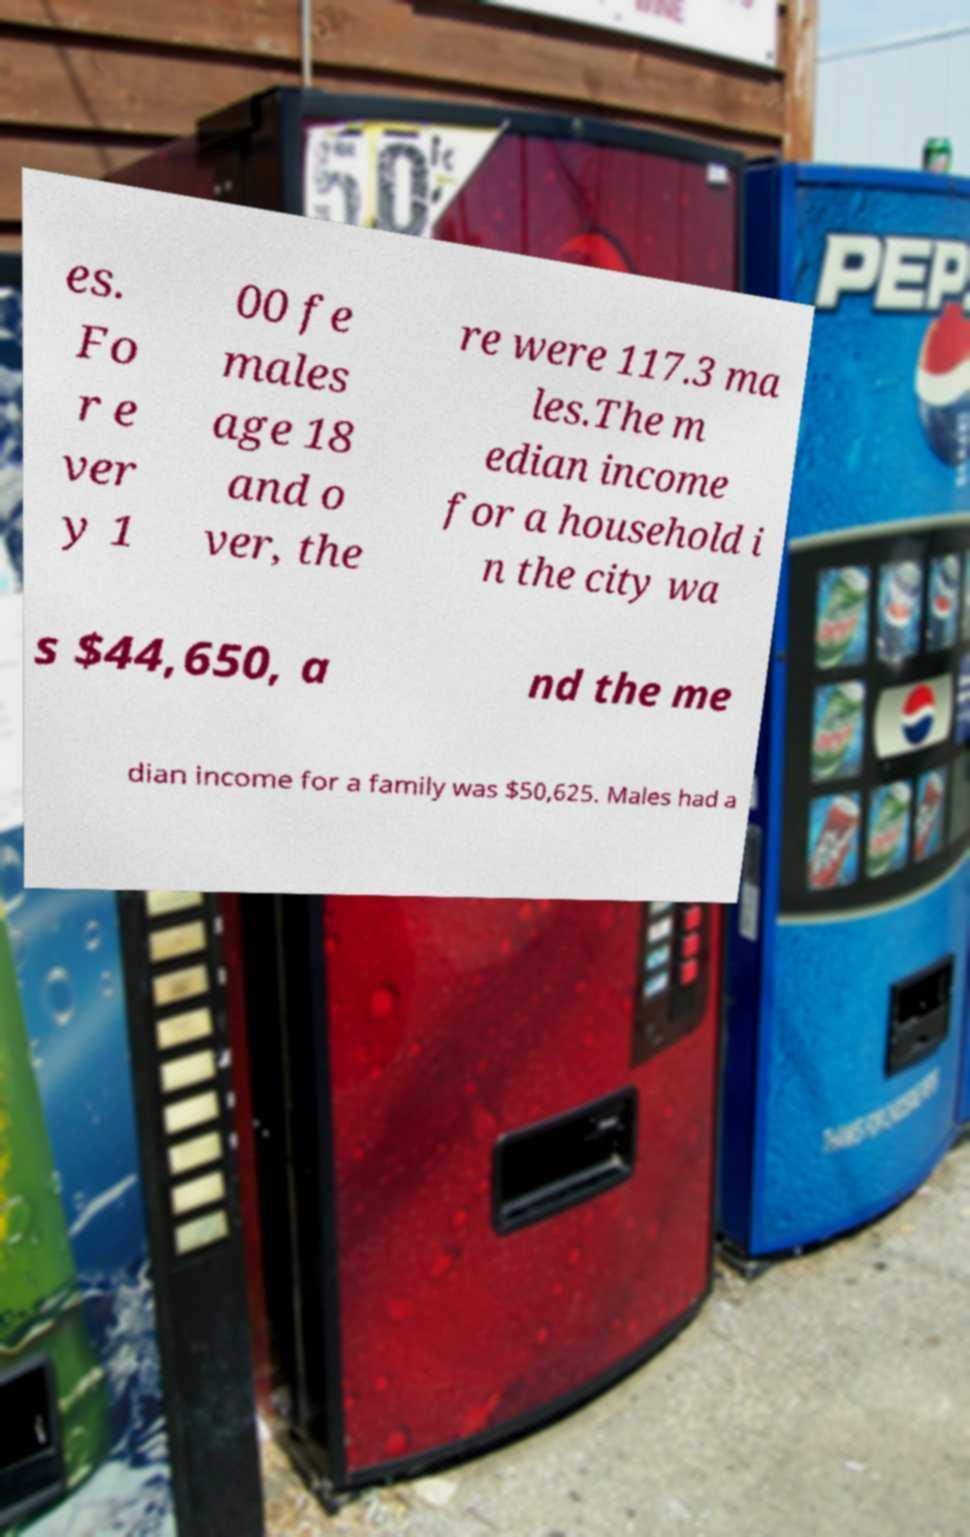Please read and relay the text visible in this image. What does it say? es. Fo r e ver y 1 00 fe males age 18 and o ver, the re were 117.3 ma les.The m edian income for a household i n the city wa s $44,650, a nd the me dian income for a family was $50,625. Males had a 